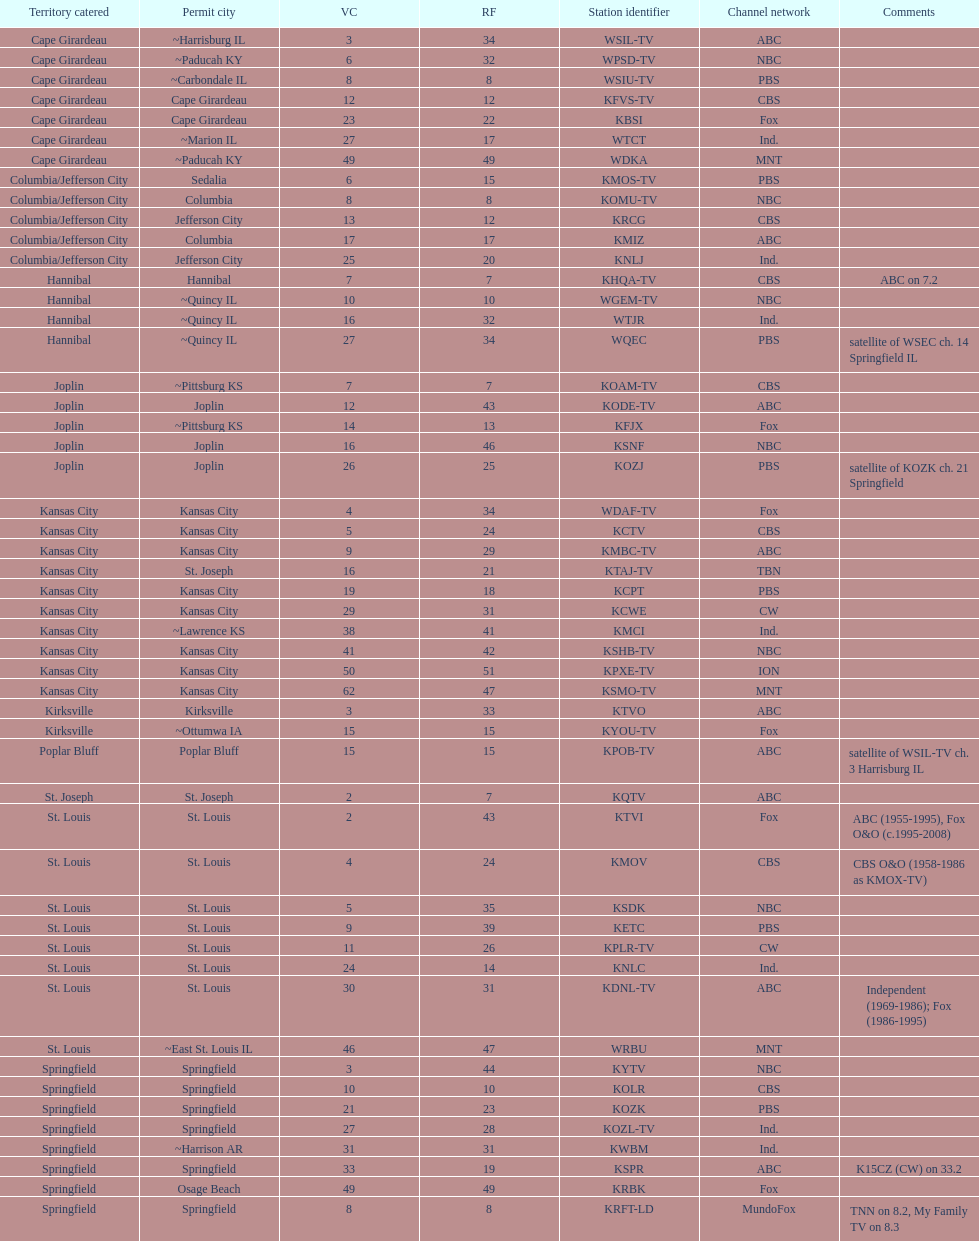What is the total number of cbs stations? 7. 